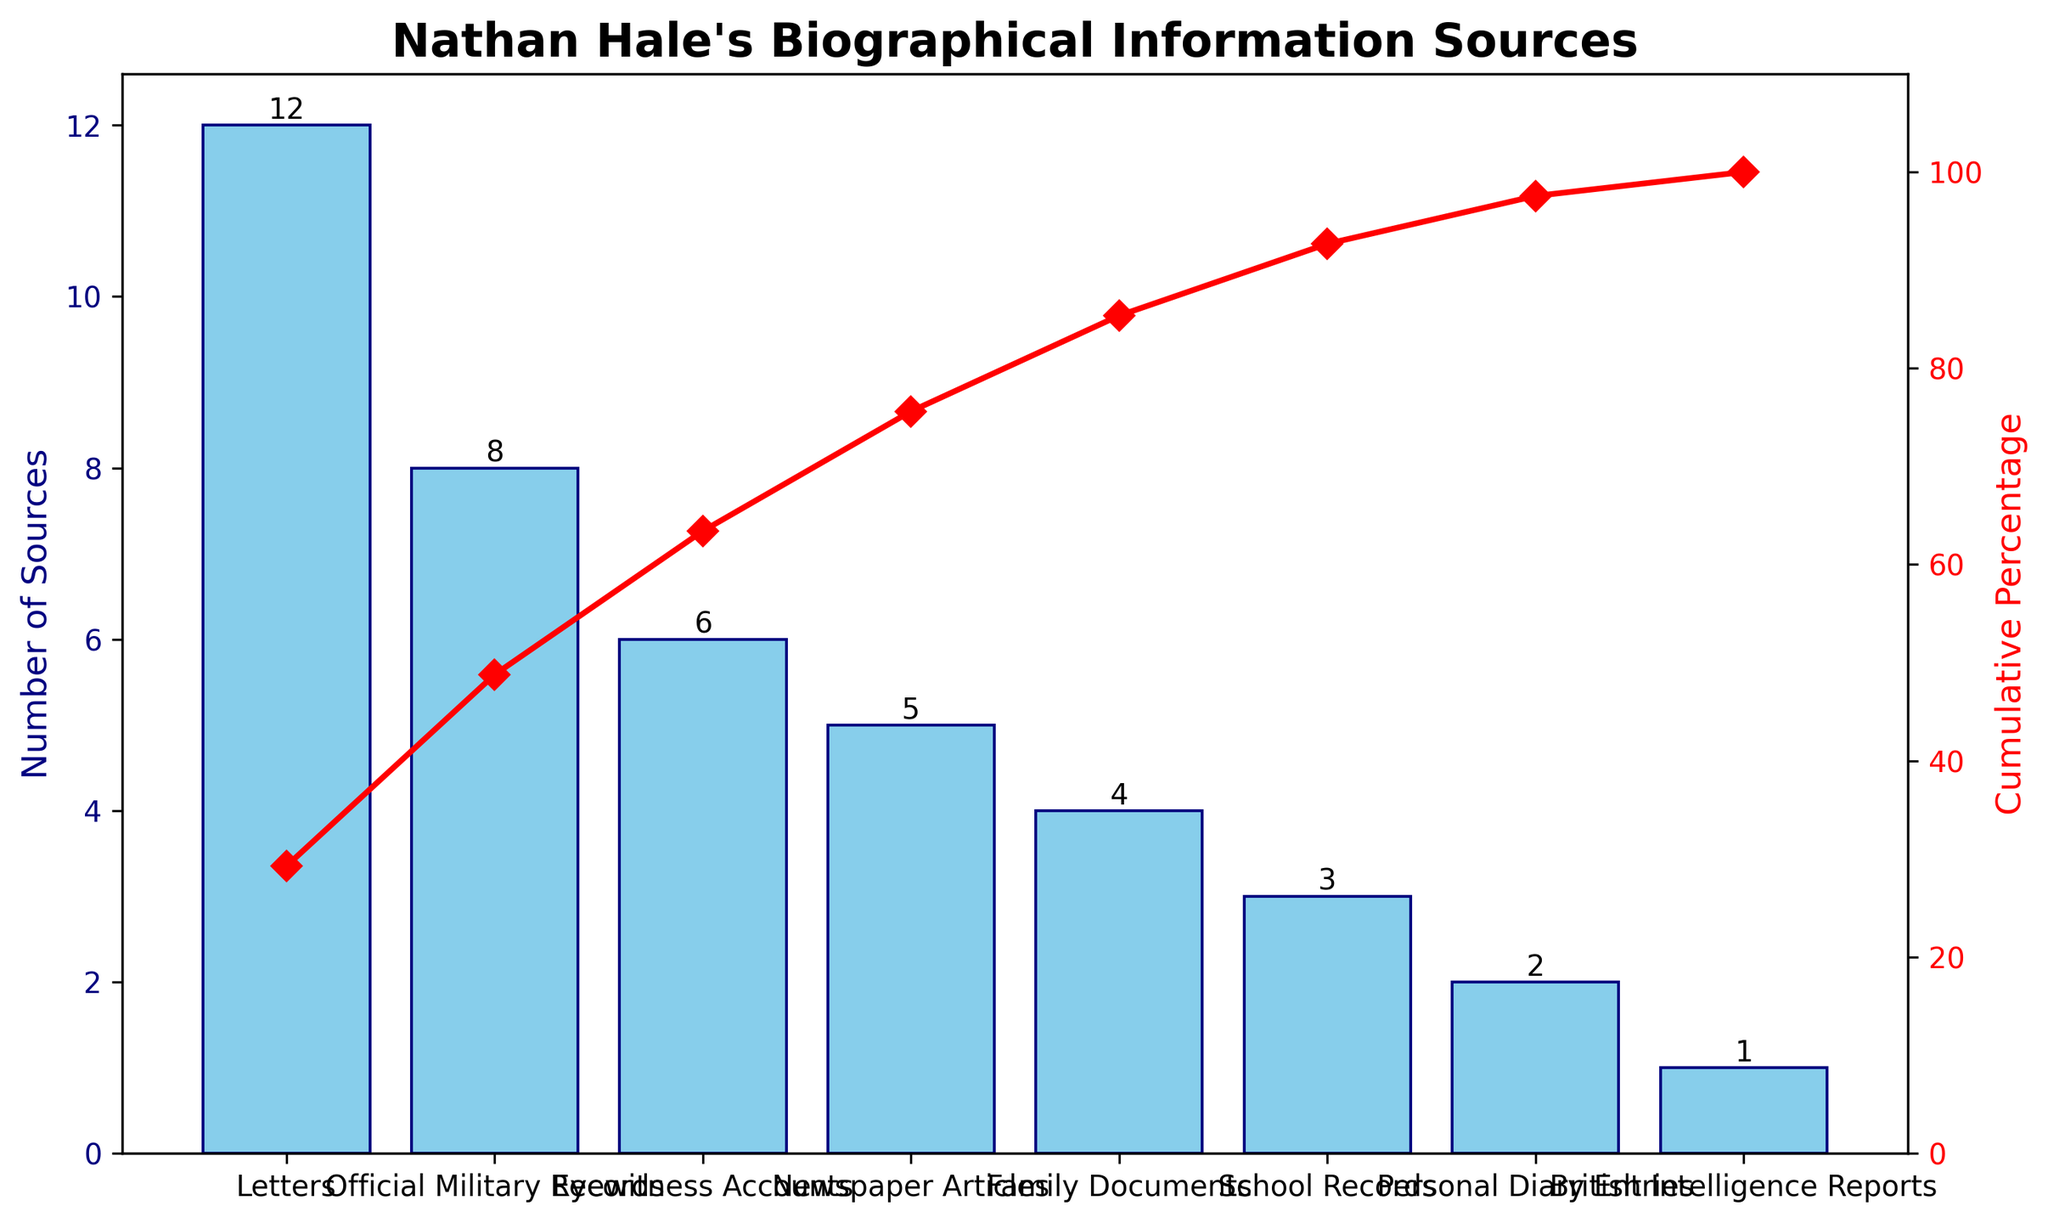What is the title of the figure? The title of the figure can be found at the top of the chart. It reads "Nathan Hale's Biographical Information Sources" which indicates the subject and the main focus of the chart.
Answer: Nathan Hale's Biographical Information Sources Which type of source has the largest number of entries? The bars at the bottom of each source type show the number of entries. The tallest bar represents the source type with the largest number, which is "Letters" with 12 entries.
Answer: Letters What are the colors used for the bars and the cumulative percentage line? The bar color is sky blue with a navy edge, and the cumulative percentage line is red with diamond markers.
Answer: Sky blue and red How many types of biographical information sources are there in the chart? Count the distinct labels on the x-axis which represent each type of source. There are 8 different types.
Answer: 8 What's the cumulative percentage after including the "Eyewitness Accounts"? The red line intersecting with the bar labeled "Eyewitness Accounts" shows the cumulative percentage. This value is around 75% on the secondary y-axis.
Answer: 75% How many fewer "British Intelligence Reports" are there compared to "Official Military Records"? The bar for "Official Military Records" shows 8 entries and the bar for "British Intelligence Reports" shows 1 entry. The difference is 8 - 1.
Answer: 7 Arrange the types of sources in descending order of the number of entries. Look at the heights of the bars from left (largest) to right (smallest) and write down the labels in that order: Letters, Official Military Records, Eyewitness Accounts, Newspaper Articles, Family Documents, School Records, Personal Diary Entries, British Intelligence Reports.
Answer: Letters, Official Military Records, Eyewitness Accounts, Newspaper Articles, Family Documents, School Records, Personal Diary Entries, British Intelligence Reports What is the number of sources for the third most frequent source type? The third source type from left to right is "Eyewitness Accounts," and the bar height for this type shows a value of 6.
Answer: 6 How many percentage points does the cumulative percentage increase from "Family Documents" to "Personal Diary Entries"? The cumulative percentage at "Family Documents" is around 88%, and at "Personal Diary Entries," it is about 97%. The difference is 97% - 88%.
Answer: 9% Which source types are needed to reach at least 50% cumulative coverage? Looking at the cumulative line: "Letters" (12), "Official Military Records" (8), and "Eyewitness Accounts" (6) add up to 26, which is more than half of the total number (41).
Answer: Letters, Official Military Records, Eyewitness Accounts 